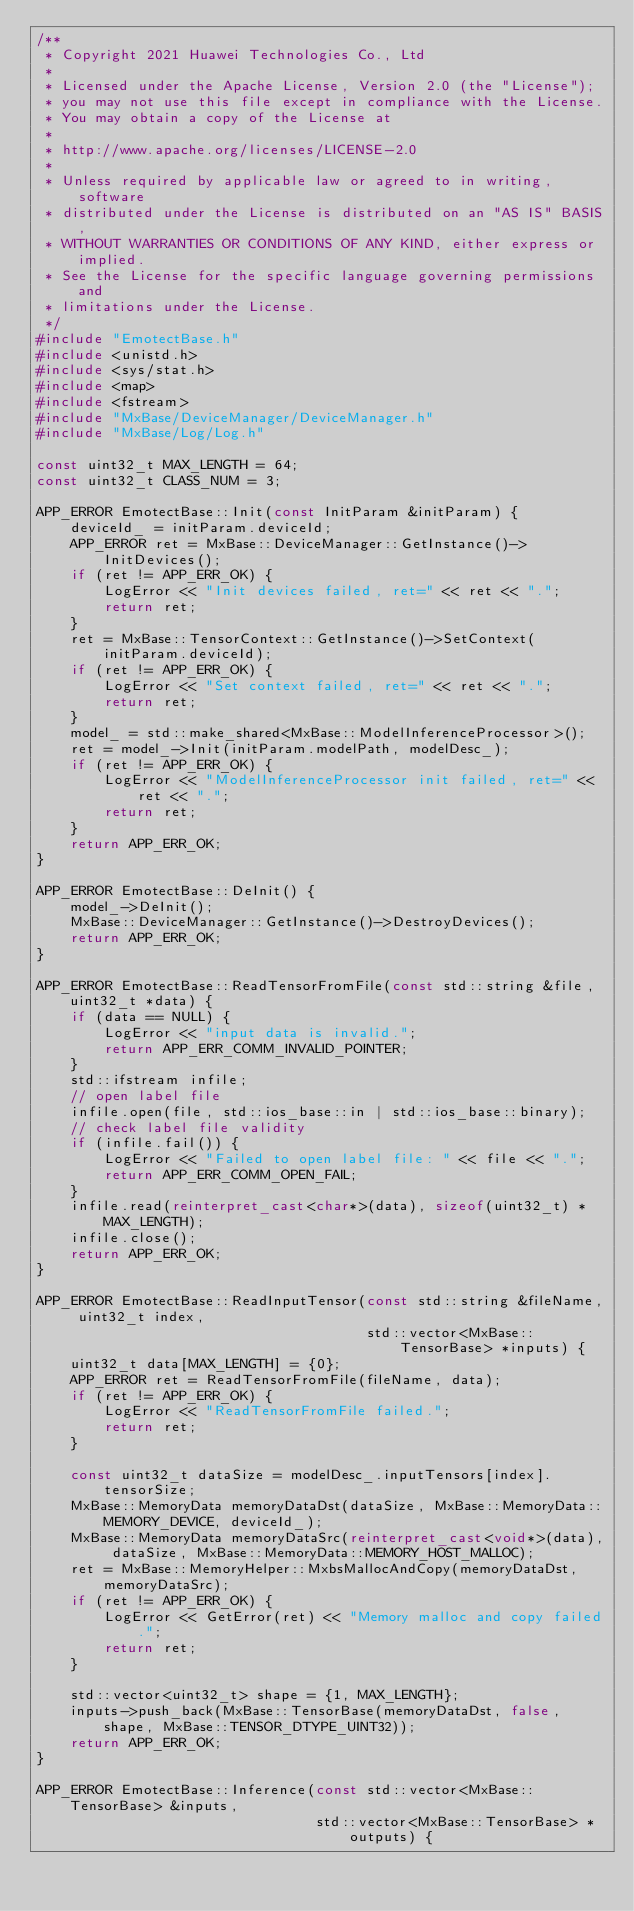<code> <loc_0><loc_0><loc_500><loc_500><_C++_>/**
 * Copyright 2021 Huawei Technologies Co., Ltd
 *
 * Licensed under the Apache License, Version 2.0 (the "License");
 * you may not use this file except in compliance with the License.
 * You may obtain a copy of the License at
 *
 * http://www.apache.org/licenses/LICENSE-2.0
 *
 * Unless required by applicable law or agreed to in writing, software
 * distributed under the License is distributed on an "AS IS" BASIS,
 * WITHOUT WARRANTIES OR CONDITIONS OF ANY KIND, either express or implied.
 * See the License for the specific language governing permissions and
 * limitations under the License.
 */
#include "EmotectBase.h"
#include <unistd.h>
#include <sys/stat.h>
#include <map>
#include <fstream>
#include "MxBase/DeviceManager/DeviceManager.h"
#include "MxBase/Log/Log.h"

const uint32_t MAX_LENGTH = 64;
const uint32_t CLASS_NUM = 3;

APP_ERROR EmotectBase::Init(const InitParam &initParam) {
    deviceId_ = initParam.deviceId;
    APP_ERROR ret = MxBase::DeviceManager::GetInstance()->InitDevices();
    if (ret != APP_ERR_OK) {
        LogError << "Init devices failed, ret=" << ret << ".";
        return ret;
    }
    ret = MxBase::TensorContext::GetInstance()->SetContext(initParam.deviceId);
    if (ret != APP_ERR_OK) {
        LogError << "Set context failed, ret=" << ret << ".";
        return ret;
    }
    model_ = std::make_shared<MxBase::ModelInferenceProcessor>();
    ret = model_->Init(initParam.modelPath, modelDesc_);
    if (ret != APP_ERR_OK) {
        LogError << "ModelInferenceProcessor init failed, ret=" << ret << ".";
        return ret;
    }
    return APP_ERR_OK;
}

APP_ERROR EmotectBase::DeInit() {
    model_->DeInit();
    MxBase::DeviceManager::GetInstance()->DestroyDevices();
    return APP_ERR_OK;
}

APP_ERROR EmotectBase::ReadTensorFromFile(const std::string &file, uint32_t *data) {
    if (data == NULL) {
        LogError << "input data is invalid.";
        return APP_ERR_COMM_INVALID_POINTER;
    }
    std::ifstream infile;
    // open label file
    infile.open(file, std::ios_base::in | std::ios_base::binary);
    // check label file validity
    if (infile.fail()) {
        LogError << "Failed to open label file: " << file << ".";
        return APP_ERR_COMM_OPEN_FAIL;
    }
    infile.read(reinterpret_cast<char*>(data), sizeof(uint32_t) * MAX_LENGTH);
    infile.close();
    return APP_ERR_OK;
}

APP_ERROR EmotectBase::ReadInputTensor(const std::string &fileName, uint32_t index,
                                       std::vector<MxBase::TensorBase> *inputs) {
    uint32_t data[MAX_LENGTH] = {0};
    APP_ERROR ret = ReadTensorFromFile(fileName, data);
    if (ret != APP_ERR_OK) {
        LogError << "ReadTensorFromFile failed.";
        return ret;
    }

    const uint32_t dataSize = modelDesc_.inputTensors[index].tensorSize;
    MxBase::MemoryData memoryDataDst(dataSize, MxBase::MemoryData::MEMORY_DEVICE, deviceId_);
    MxBase::MemoryData memoryDataSrc(reinterpret_cast<void*>(data), dataSize, MxBase::MemoryData::MEMORY_HOST_MALLOC);
    ret = MxBase::MemoryHelper::MxbsMallocAndCopy(memoryDataDst, memoryDataSrc);
    if (ret != APP_ERR_OK) {
        LogError << GetError(ret) << "Memory malloc and copy failed.";
        return ret;
    }

    std::vector<uint32_t> shape = {1, MAX_LENGTH};
    inputs->push_back(MxBase::TensorBase(memoryDataDst, false, shape, MxBase::TENSOR_DTYPE_UINT32));
    return APP_ERR_OK;
}

APP_ERROR EmotectBase::Inference(const std::vector<MxBase::TensorBase> &inputs,
                                 std::vector<MxBase::TensorBase> *outputs) {</code> 